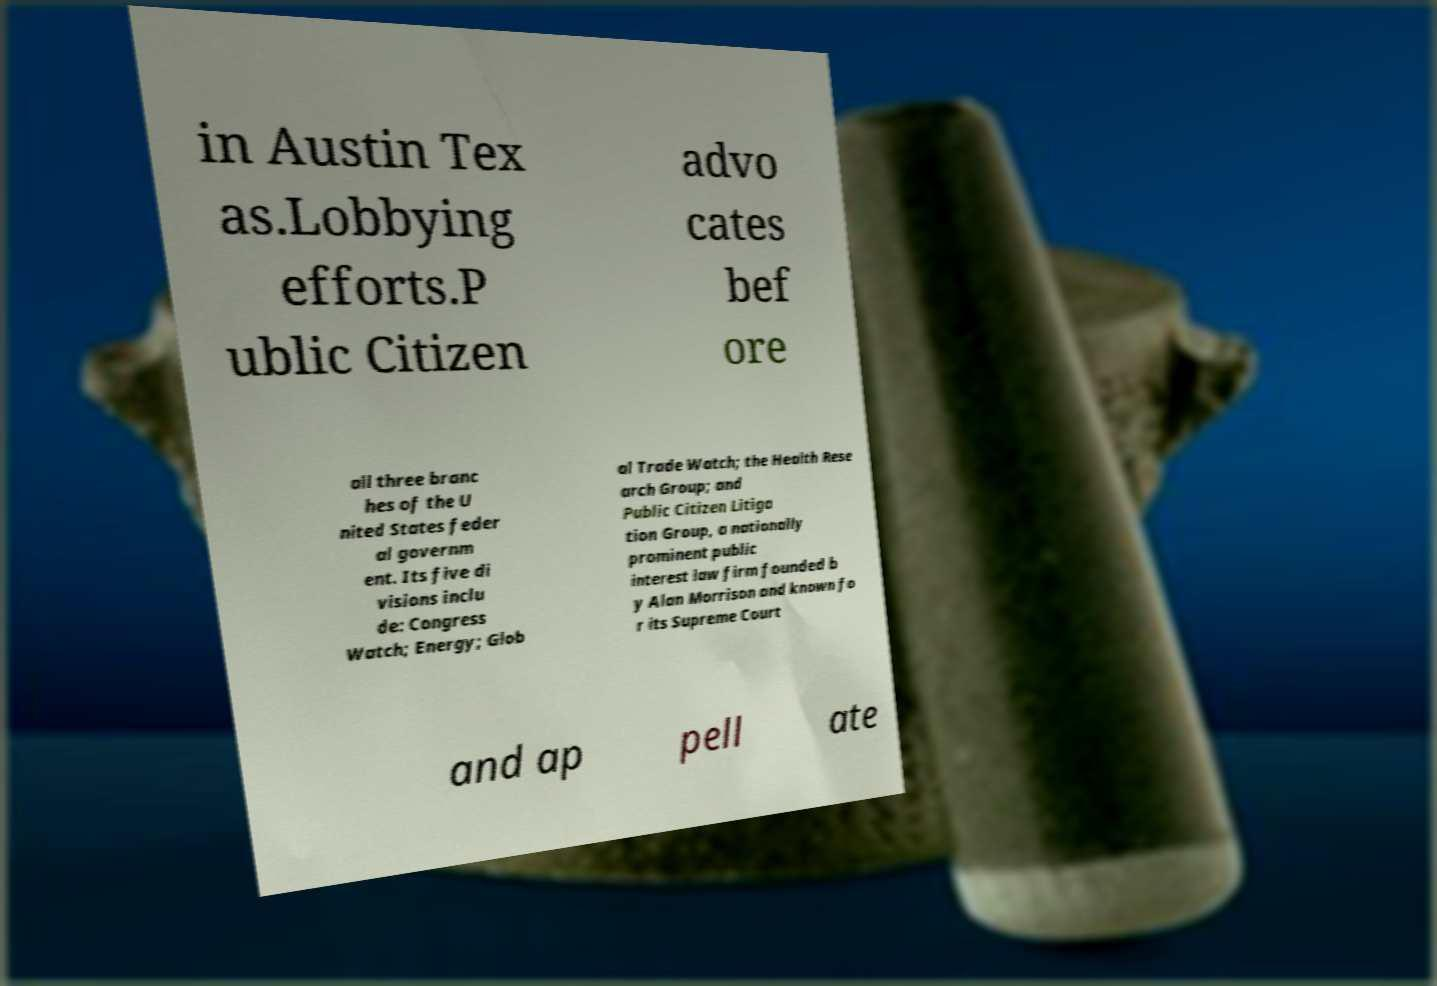Could you extract and type out the text from this image? in Austin Tex as.Lobbying efforts.P ublic Citizen advo cates bef ore all three branc hes of the U nited States feder al governm ent. Its five di visions inclu de: Congress Watch; Energy; Glob al Trade Watch; the Health Rese arch Group; and Public Citizen Litiga tion Group, a nationally prominent public interest law firm founded b y Alan Morrison and known fo r its Supreme Court and ap pell ate 